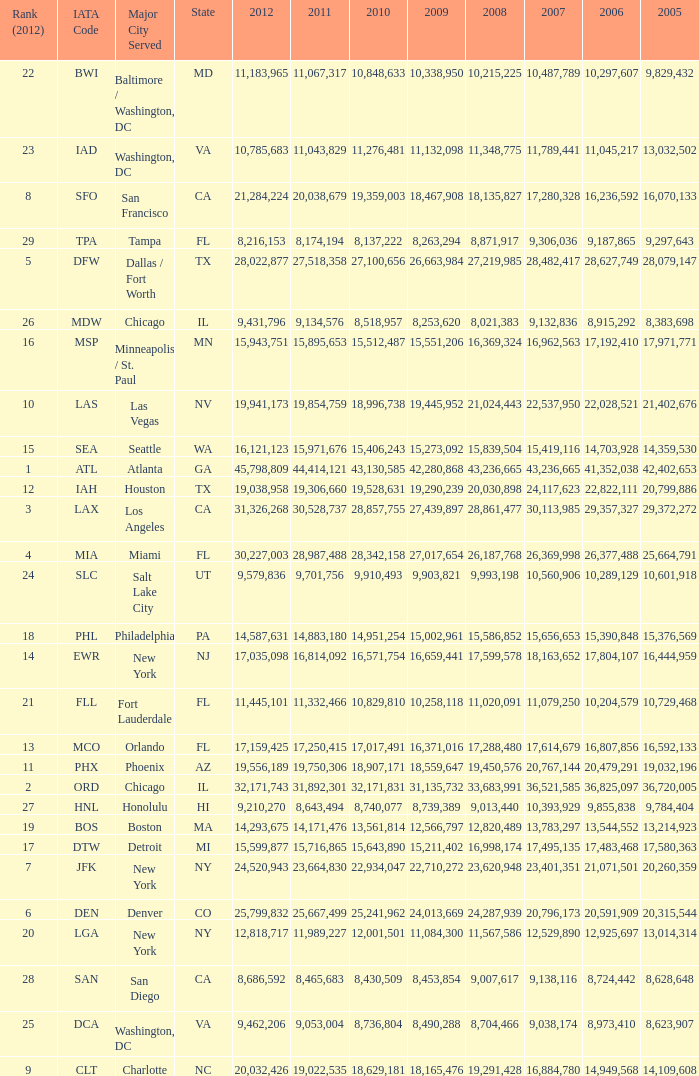What is the greatest 2010 for Miami, Fl? 28342158.0. 